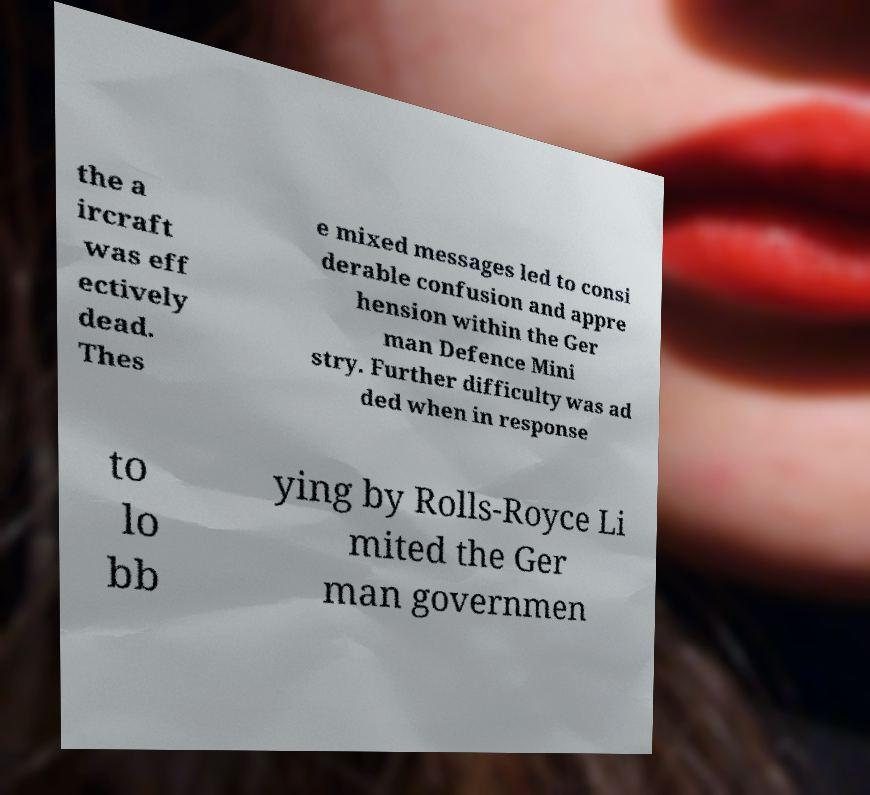Please read and relay the text visible in this image. What does it say? the a ircraft was eff ectively dead. Thes e mixed messages led to consi derable confusion and appre hension within the Ger man Defence Mini stry. Further difficulty was ad ded when in response to lo bb ying by Rolls-Royce Li mited the Ger man governmen 